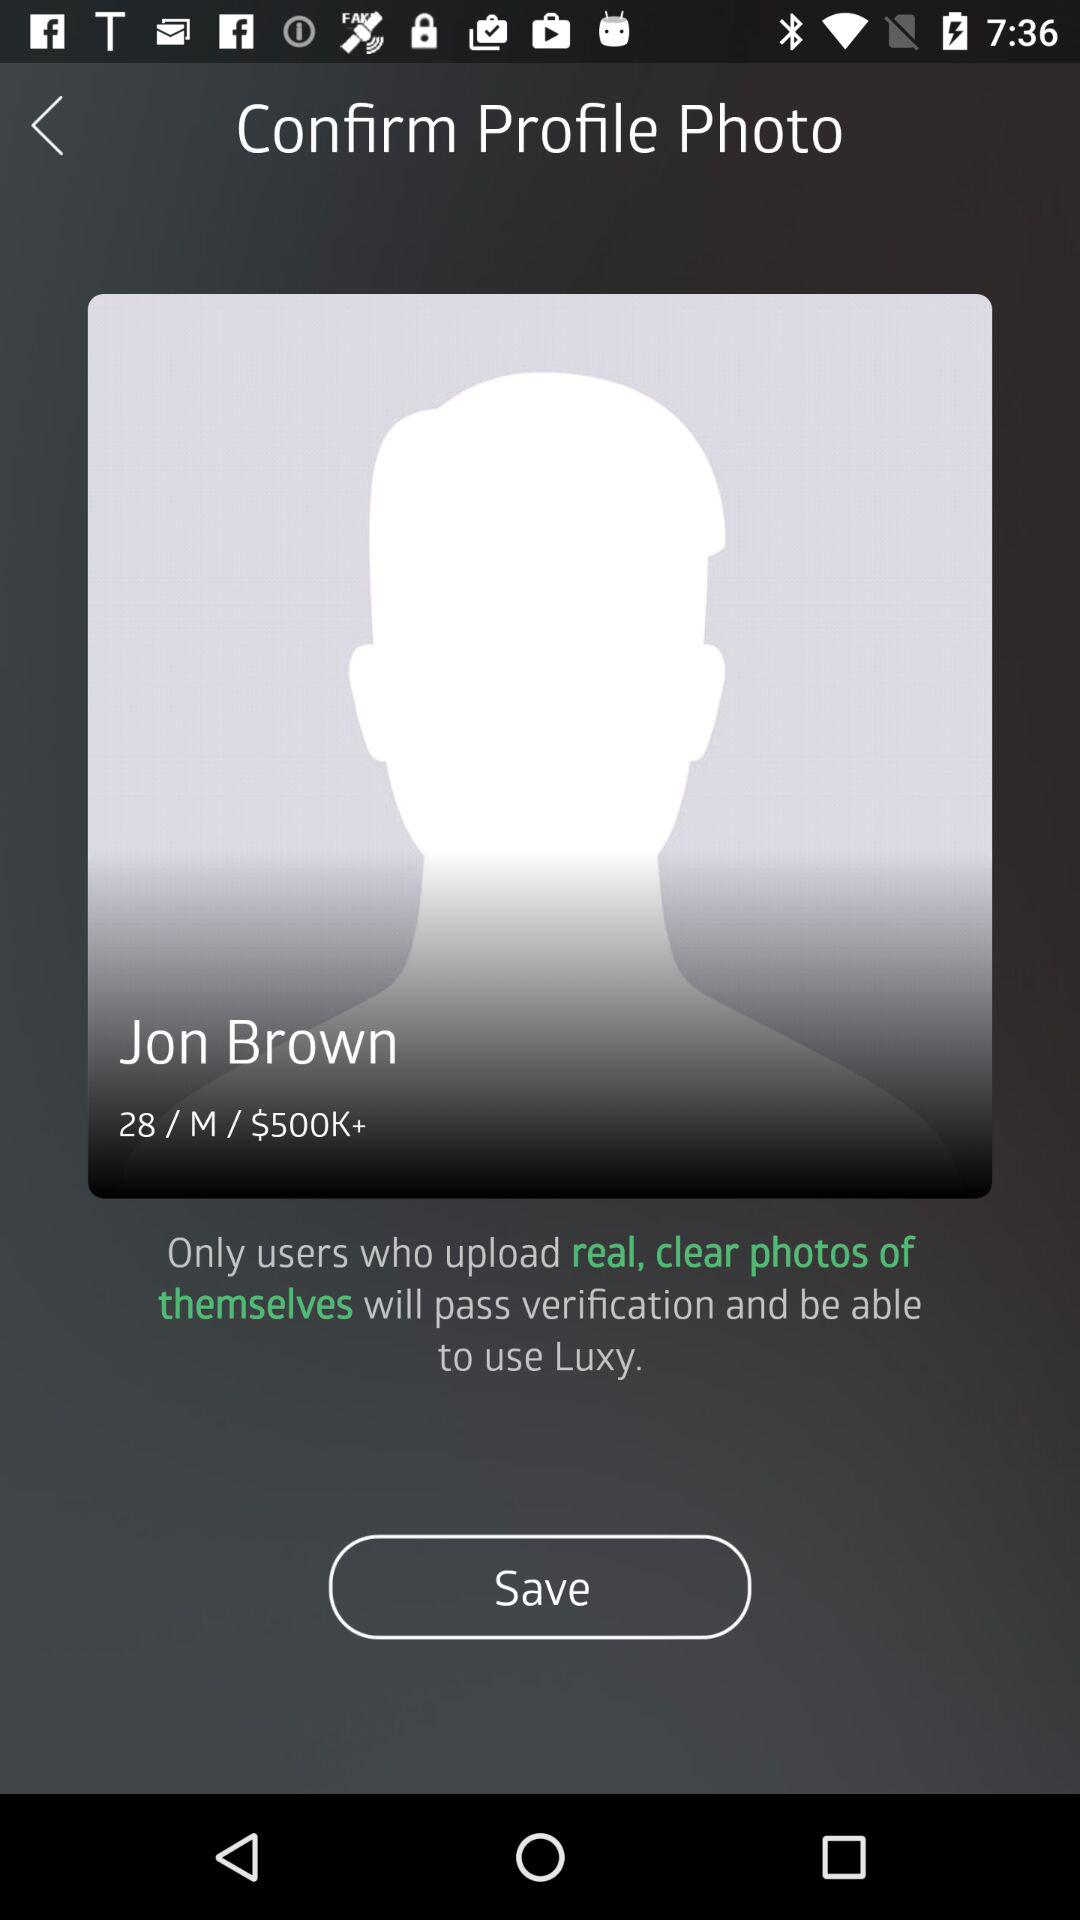Is Jon Brown male or female? Jon Brown is a male. 